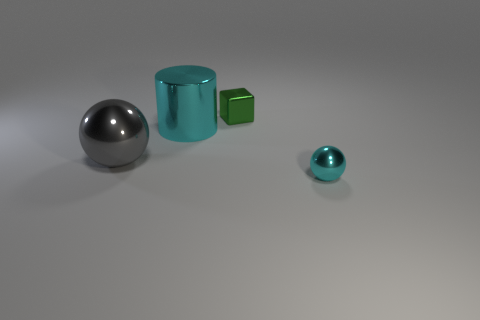What is the size of the cylinder?
Give a very brief answer. Large. There is a cylinder; does it have the same color as the ball in front of the gray shiny thing?
Offer a terse response. Yes. How many other things are there of the same color as the cylinder?
Offer a very short reply. 1. There is a cyan thing that is behind the big gray metallic thing; does it have the same size as the thing that is behind the large cyan thing?
Your answer should be very brief. No. The small thing that is in front of the cylinder is what color?
Your answer should be compact. Cyan. Is the number of small blocks that are behind the large shiny cylinder less than the number of metallic balls?
Ensure brevity in your answer.  Yes. Do the green block and the cyan sphere have the same material?
Your answer should be very brief. Yes. What size is the other shiny thing that is the same shape as the small cyan object?
Make the answer very short. Large. How many things are either large shiny things that are right of the big gray metal ball or things that are behind the small ball?
Offer a very short reply. 3. Are there fewer big cyan cylinders than spheres?
Provide a succinct answer. Yes. 